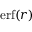Convert formula to latex. <formula><loc_0><loc_0><loc_500><loc_500>e r f ( r )</formula> 